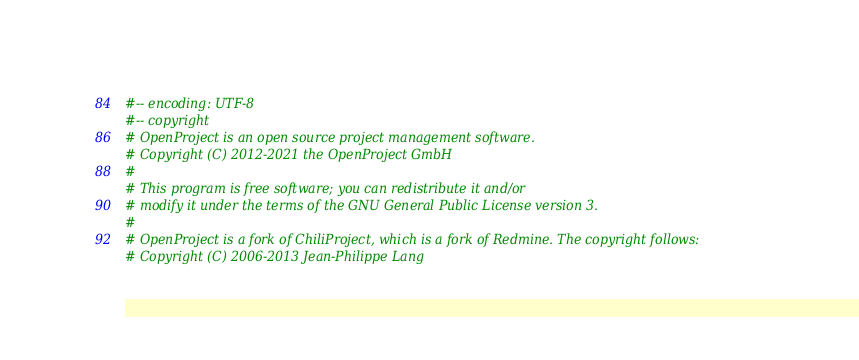Convert code to text. <code><loc_0><loc_0><loc_500><loc_500><_Ruby_>#-- encoding: UTF-8
#-- copyright
# OpenProject is an open source project management software.
# Copyright (C) 2012-2021 the OpenProject GmbH
#
# This program is free software; you can redistribute it and/or
# modify it under the terms of the GNU General Public License version 3.
#
# OpenProject is a fork of ChiliProject, which is a fork of Redmine. The copyright follows:
# Copyright (C) 2006-2013 Jean-Philippe Lang</code> 